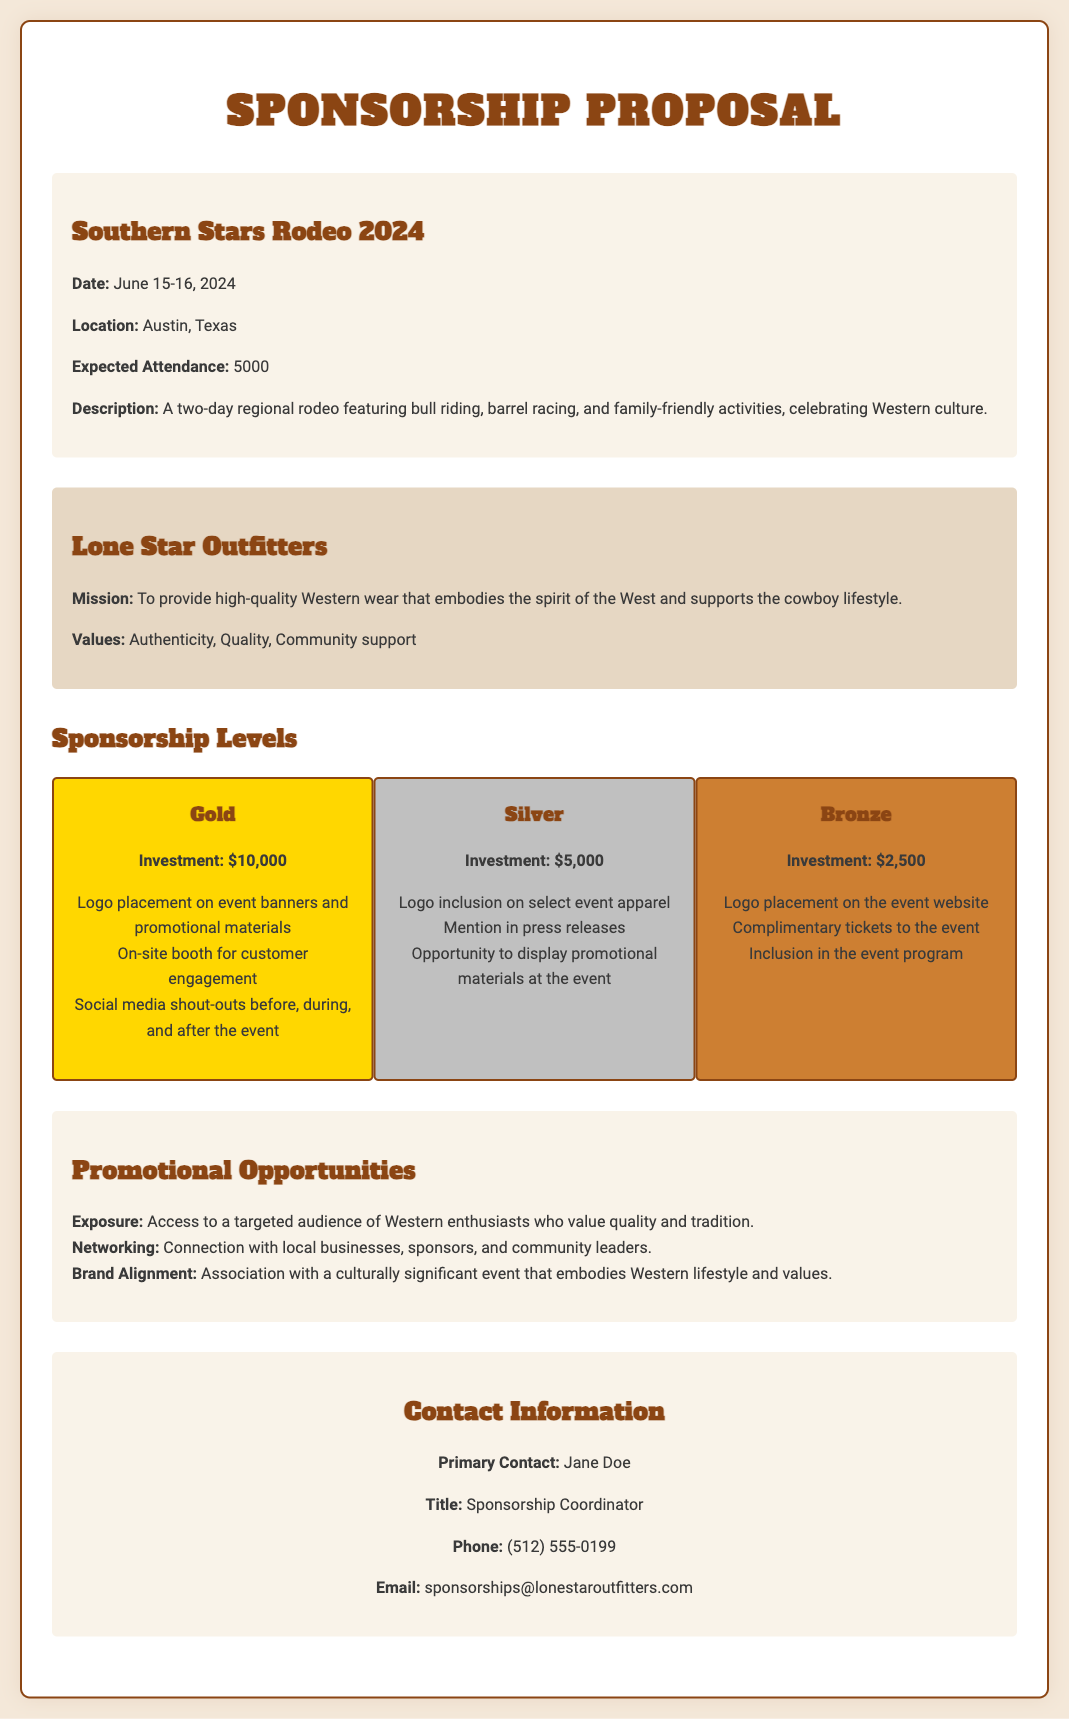What are the event dates? The event dates are explicitly stated in the document as June 15-16, 2024.
Answer: June 15-16, 2024 Where is the Southern Stars Rodeo taking place? The location of the rodeo is mentioned in the document, specified as Austin, Texas.
Answer: Austin, Texas What is the expected attendance for the event? The document provides the expected attendance as 5000.
Answer: 5000 What is the investment for the Gold sponsorship level? The document lists the investment for the Gold sponsorship level as $10,000.
Answer: $10,000 What values does Lone Star Outfitters support? The document clearly states the values as Authenticity, Quality, Community support.
Answer: Authenticity, Quality, Community support What promotional opportunity involves access to a targeted audience? The exposure to a targeted audience is explicitly mentioned as one of the promotional opportunities in the document.
Answer: Exposure How does sponsorship at the rodeo facilitate networking? The document highlights networking as connecting with local businesses, sponsors, and community leaders.
Answer: Local businesses, sponsors, community leaders What is the title of the primary contact for sponsorships? The primary contact's title is provided in the document, which is Sponsorship Coordinator.
Answer: Sponsorship Coordinator What type of event is the Southern Stars Rodeo? The document describes it as a regional rodeo featuring bull riding, barrel racing, and family-friendly activities.
Answer: Regional rodeo 